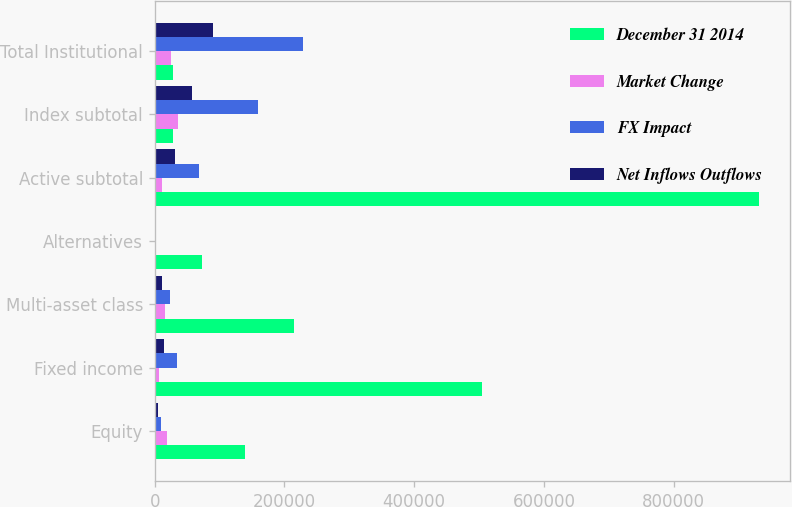Convert chart to OTSL. <chart><loc_0><loc_0><loc_500><loc_500><stacked_bar_chart><ecel><fcel>Equity<fcel>Fixed income<fcel>Multi-asset class<fcel>Alternatives<fcel>Active subtotal<fcel>Index subtotal<fcel>Total Institutional<nl><fcel>December 31 2014<fcel>138726<fcel>505109<fcel>215276<fcel>73299<fcel>932410<fcel>28732<fcel>28732<nl><fcel>Market Change<fcel>18648<fcel>6943<fcel>15835<fcel>664<fcel>10420<fcel>36128<fcel>25708<nl><fcel>FX Impact<fcel>9935<fcel>34062<fcel>23435<fcel>1494<fcel>68926<fcel>159594<fcel>228520<nl><fcel>Net Inflows Outflows<fcel>4870<fcel>13638<fcel>11633<fcel>1615<fcel>31756<fcel>57248<fcel>89004<nl></chart> 